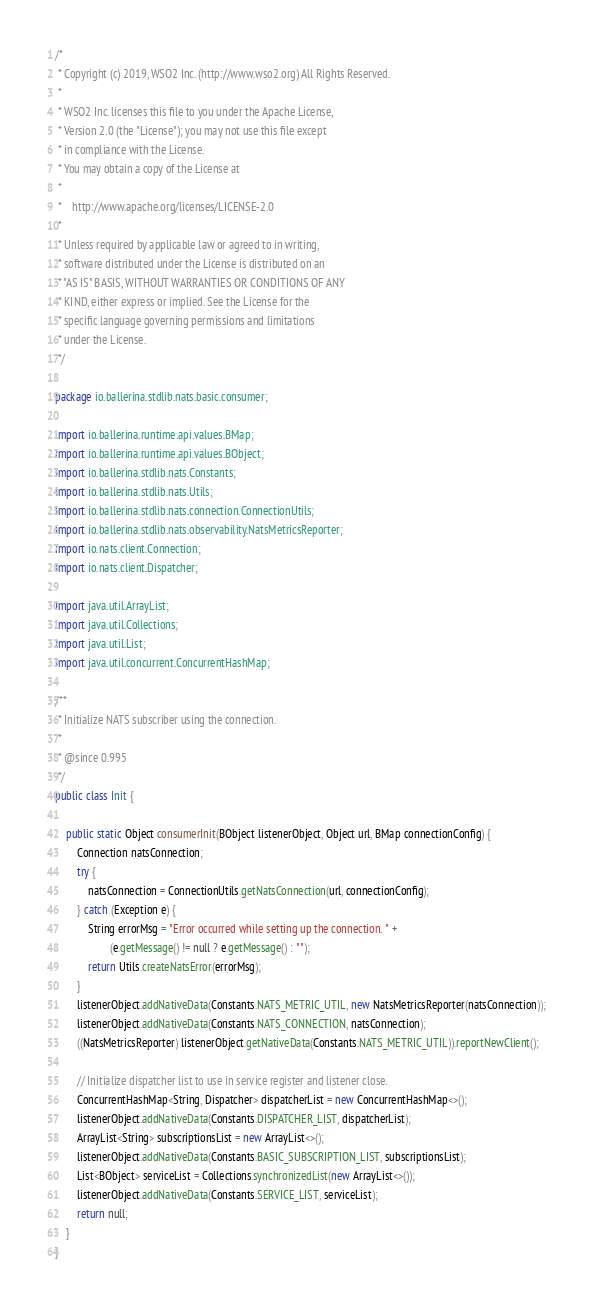<code> <loc_0><loc_0><loc_500><loc_500><_Java_>/*
 * Copyright (c) 2019, WSO2 Inc. (http://www.wso2.org) All Rights Reserved.
 *
 * WSO2 Inc. licenses this file to you under the Apache License,
 * Version 2.0 (the "License"); you may not use this file except
 * in compliance with the License.
 * You may obtain a copy of the License at
 *
 *    http://www.apache.org/licenses/LICENSE-2.0
 *
 * Unless required by applicable law or agreed to in writing,
 * software distributed under the License is distributed on an
 * "AS IS" BASIS, WITHOUT WARRANTIES OR CONDITIONS OF ANY
 * KIND, either express or implied. See the License for the
 * specific language governing permissions and limitations
 * under the License.
 */

package io.ballerina.stdlib.nats.basic.consumer;

import io.ballerina.runtime.api.values.BMap;
import io.ballerina.runtime.api.values.BObject;
import io.ballerina.stdlib.nats.Constants;
import io.ballerina.stdlib.nats.Utils;
import io.ballerina.stdlib.nats.connection.ConnectionUtils;
import io.ballerina.stdlib.nats.observability.NatsMetricsReporter;
import io.nats.client.Connection;
import io.nats.client.Dispatcher;

import java.util.ArrayList;
import java.util.Collections;
import java.util.List;
import java.util.concurrent.ConcurrentHashMap;

/**
 * Initialize NATS subscriber using the connection.
 *
 * @since 0.995
 */
public class Init {

    public static Object consumerInit(BObject listenerObject, Object url, BMap connectionConfig) {
        Connection natsConnection;
        try {
            natsConnection = ConnectionUtils.getNatsConnection(url, connectionConfig);
        } catch (Exception e) {
            String errorMsg = "Error occurred while setting up the connection. " +
                    (e.getMessage() != null ? e.getMessage() : "");
            return Utils.createNatsError(errorMsg);
        }
        listenerObject.addNativeData(Constants.NATS_METRIC_UTIL, new NatsMetricsReporter(natsConnection));
        listenerObject.addNativeData(Constants.NATS_CONNECTION, natsConnection);
        ((NatsMetricsReporter) listenerObject.getNativeData(Constants.NATS_METRIC_UTIL)).reportNewClient();

        // Initialize dispatcher list to use in service register and listener close.
        ConcurrentHashMap<String, Dispatcher> dispatcherList = new ConcurrentHashMap<>();
        listenerObject.addNativeData(Constants.DISPATCHER_LIST, dispatcherList);
        ArrayList<String> subscriptionsList = new ArrayList<>();
        listenerObject.addNativeData(Constants.BASIC_SUBSCRIPTION_LIST, subscriptionsList);
        List<BObject> serviceList = Collections.synchronizedList(new ArrayList<>());
        listenerObject.addNativeData(Constants.SERVICE_LIST, serviceList);
        return null;
    }
}
</code> 